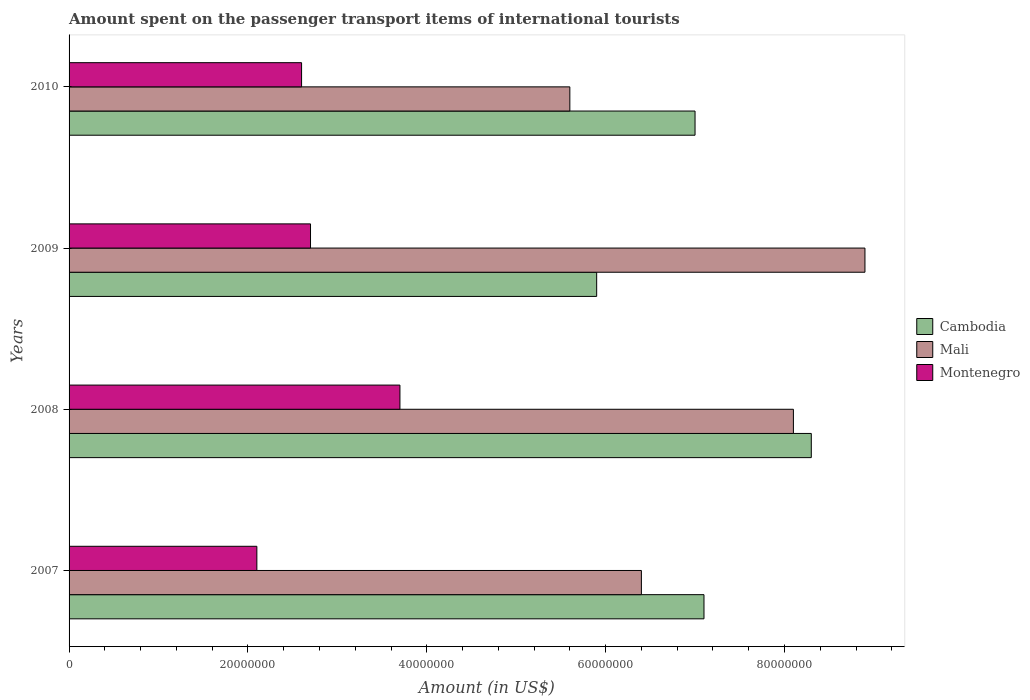How many different coloured bars are there?
Your answer should be compact. 3. Are the number of bars on each tick of the Y-axis equal?
Offer a very short reply. Yes. In how many cases, is the number of bars for a given year not equal to the number of legend labels?
Provide a succinct answer. 0. What is the amount spent on the passenger transport items of international tourists in Montenegro in 2008?
Ensure brevity in your answer.  3.70e+07. Across all years, what is the maximum amount spent on the passenger transport items of international tourists in Mali?
Provide a short and direct response. 8.90e+07. Across all years, what is the minimum amount spent on the passenger transport items of international tourists in Mali?
Keep it short and to the point. 5.60e+07. In which year was the amount spent on the passenger transport items of international tourists in Montenegro maximum?
Ensure brevity in your answer.  2008. What is the total amount spent on the passenger transport items of international tourists in Mali in the graph?
Provide a short and direct response. 2.90e+08. What is the difference between the amount spent on the passenger transport items of international tourists in Cambodia in 2007 and that in 2008?
Give a very brief answer. -1.20e+07. What is the difference between the amount spent on the passenger transport items of international tourists in Mali in 2008 and the amount spent on the passenger transport items of international tourists in Montenegro in 2007?
Provide a succinct answer. 6.00e+07. What is the average amount spent on the passenger transport items of international tourists in Mali per year?
Your answer should be compact. 7.25e+07. In the year 2009, what is the difference between the amount spent on the passenger transport items of international tourists in Mali and amount spent on the passenger transport items of international tourists in Cambodia?
Provide a short and direct response. 3.00e+07. In how many years, is the amount spent on the passenger transport items of international tourists in Cambodia greater than 4000000 US$?
Offer a very short reply. 4. What is the ratio of the amount spent on the passenger transport items of international tourists in Cambodia in 2007 to that in 2010?
Make the answer very short. 1.01. Is the difference between the amount spent on the passenger transport items of international tourists in Mali in 2007 and 2010 greater than the difference between the amount spent on the passenger transport items of international tourists in Cambodia in 2007 and 2010?
Give a very brief answer. Yes. What is the difference between the highest and the second highest amount spent on the passenger transport items of international tourists in Mali?
Provide a succinct answer. 8.00e+06. What is the difference between the highest and the lowest amount spent on the passenger transport items of international tourists in Mali?
Provide a short and direct response. 3.30e+07. In how many years, is the amount spent on the passenger transport items of international tourists in Montenegro greater than the average amount spent on the passenger transport items of international tourists in Montenegro taken over all years?
Ensure brevity in your answer.  1. Is the sum of the amount spent on the passenger transport items of international tourists in Cambodia in 2008 and 2010 greater than the maximum amount spent on the passenger transport items of international tourists in Montenegro across all years?
Provide a succinct answer. Yes. What does the 1st bar from the top in 2007 represents?
Give a very brief answer. Montenegro. What does the 2nd bar from the bottom in 2007 represents?
Your answer should be very brief. Mali. What is the difference between two consecutive major ticks on the X-axis?
Keep it short and to the point. 2.00e+07. Are the values on the major ticks of X-axis written in scientific E-notation?
Offer a very short reply. No. Does the graph contain grids?
Your answer should be very brief. No. How many legend labels are there?
Give a very brief answer. 3. How are the legend labels stacked?
Offer a very short reply. Vertical. What is the title of the graph?
Your answer should be very brief. Amount spent on the passenger transport items of international tourists. Does "Chile" appear as one of the legend labels in the graph?
Ensure brevity in your answer.  No. What is the label or title of the X-axis?
Provide a succinct answer. Amount (in US$). What is the label or title of the Y-axis?
Offer a very short reply. Years. What is the Amount (in US$) of Cambodia in 2007?
Your answer should be very brief. 7.10e+07. What is the Amount (in US$) in Mali in 2007?
Provide a succinct answer. 6.40e+07. What is the Amount (in US$) in Montenegro in 2007?
Your response must be concise. 2.10e+07. What is the Amount (in US$) of Cambodia in 2008?
Make the answer very short. 8.30e+07. What is the Amount (in US$) in Mali in 2008?
Provide a short and direct response. 8.10e+07. What is the Amount (in US$) of Montenegro in 2008?
Ensure brevity in your answer.  3.70e+07. What is the Amount (in US$) of Cambodia in 2009?
Make the answer very short. 5.90e+07. What is the Amount (in US$) in Mali in 2009?
Ensure brevity in your answer.  8.90e+07. What is the Amount (in US$) of Montenegro in 2009?
Provide a short and direct response. 2.70e+07. What is the Amount (in US$) of Cambodia in 2010?
Keep it short and to the point. 7.00e+07. What is the Amount (in US$) in Mali in 2010?
Provide a succinct answer. 5.60e+07. What is the Amount (in US$) of Montenegro in 2010?
Offer a very short reply. 2.60e+07. Across all years, what is the maximum Amount (in US$) in Cambodia?
Your answer should be very brief. 8.30e+07. Across all years, what is the maximum Amount (in US$) in Mali?
Your response must be concise. 8.90e+07. Across all years, what is the maximum Amount (in US$) in Montenegro?
Your response must be concise. 3.70e+07. Across all years, what is the minimum Amount (in US$) in Cambodia?
Ensure brevity in your answer.  5.90e+07. Across all years, what is the minimum Amount (in US$) of Mali?
Provide a short and direct response. 5.60e+07. Across all years, what is the minimum Amount (in US$) in Montenegro?
Your answer should be compact. 2.10e+07. What is the total Amount (in US$) in Cambodia in the graph?
Your answer should be very brief. 2.83e+08. What is the total Amount (in US$) of Mali in the graph?
Make the answer very short. 2.90e+08. What is the total Amount (in US$) of Montenegro in the graph?
Offer a terse response. 1.11e+08. What is the difference between the Amount (in US$) of Cambodia in 2007 and that in 2008?
Your response must be concise. -1.20e+07. What is the difference between the Amount (in US$) in Mali in 2007 and that in 2008?
Offer a terse response. -1.70e+07. What is the difference between the Amount (in US$) of Montenegro in 2007 and that in 2008?
Your answer should be compact. -1.60e+07. What is the difference between the Amount (in US$) in Cambodia in 2007 and that in 2009?
Your answer should be very brief. 1.20e+07. What is the difference between the Amount (in US$) in Mali in 2007 and that in 2009?
Keep it short and to the point. -2.50e+07. What is the difference between the Amount (in US$) of Montenegro in 2007 and that in 2009?
Give a very brief answer. -6.00e+06. What is the difference between the Amount (in US$) of Mali in 2007 and that in 2010?
Offer a terse response. 8.00e+06. What is the difference between the Amount (in US$) in Montenegro in 2007 and that in 2010?
Provide a succinct answer. -5.00e+06. What is the difference between the Amount (in US$) of Cambodia in 2008 and that in 2009?
Provide a short and direct response. 2.40e+07. What is the difference between the Amount (in US$) in Mali in 2008 and that in 2009?
Make the answer very short. -8.00e+06. What is the difference between the Amount (in US$) in Cambodia in 2008 and that in 2010?
Your answer should be compact. 1.30e+07. What is the difference between the Amount (in US$) in Mali in 2008 and that in 2010?
Give a very brief answer. 2.50e+07. What is the difference between the Amount (in US$) of Montenegro in 2008 and that in 2010?
Give a very brief answer. 1.10e+07. What is the difference between the Amount (in US$) of Cambodia in 2009 and that in 2010?
Provide a succinct answer. -1.10e+07. What is the difference between the Amount (in US$) in Mali in 2009 and that in 2010?
Offer a terse response. 3.30e+07. What is the difference between the Amount (in US$) in Montenegro in 2009 and that in 2010?
Keep it short and to the point. 1.00e+06. What is the difference between the Amount (in US$) in Cambodia in 2007 and the Amount (in US$) in Mali in 2008?
Offer a very short reply. -1.00e+07. What is the difference between the Amount (in US$) in Cambodia in 2007 and the Amount (in US$) in Montenegro in 2008?
Make the answer very short. 3.40e+07. What is the difference between the Amount (in US$) of Mali in 2007 and the Amount (in US$) of Montenegro in 2008?
Keep it short and to the point. 2.70e+07. What is the difference between the Amount (in US$) of Cambodia in 2007 and the Amount (in US$) of Mali in 2009?
Offer a terse response. -1.80e+07. What is the difference between the Amount (in US$) of Cambodia in 2007 and the Amount (in US$) of Montenegro in 2009?
Your answer should be compact. 4.40e+07. What is the difference between the Amount (in US$) of Mali in 2007 and the Amount (in US$) of Montenegro in 2009?
Provide a short and direct response. 3.70e+07. What is the difference between the Amount (in US$) in Cambodia in 2007 and the Amount (in US$) in Mali in 2010?
Give a very brief answer. 1.50e+07. What is the difference between the Amount (in US$) in Cambodia in 2007 and the Amount (in US$) in Montenegro in 2010?
Give a very brief answer. 4.50e+07. What is the difference between the Amount (in US$) of Mali in 2007 and the Amount (in US$) of Montenegro in 2010?
Keep it short and to the point. 3.80e+07. What is the difference between the Amount (in US$) of Cambodia in 2008 and the Amount (in US$) of Mali in 2009?
Provide a succinct answer. -6.00e+06. What is the difference between the Amount (in US$) in Cambodia in 2008 and the Amount (in US$) in Montenegro in 2009?
Your answer should be very brief. 5.60e+07. What is the difference between the Amount (in US$) of Mali in 2008 and the Amount (in US$) of Montenegro in 2009?
Your response must be concise. 5.40e+07. What is the difference between the Amount (in US$) in Cambodia in 2008 and the Amount (in US$) in Mali in 2010?
Provide a short and direct response. 2.70e+07. What is the difference between the Amount (in US$) in Cambodia in 2008 and the Amount (in US$) in Montenegro in 2010?
Your answer should be compact. 5.70e+07. What is the difference between the Amount (in US$) in Mali in 2008 and the Amount (in US$) in Montenegro in 2010?
Provide a short and direct response. 5.50e+07. What is the difference between the Amount (in US$) of Cambodia in 2009 and the Amount (in US$) of Montenegro in 2010?
Give a very brief answer. 3.30e+07. What is the difference between the Amount (in US$) of Mali in 2009 and the Amount (in US$) of Montenegro in 2010?
Make the answer very short. 6.30e+07. What is the average Amount (in US$) of Cambodia per year?
Give a very brief answer. 7.08e+07. What is the average Amount (in US$) in Mali per year?
Provide a short and direct response. 7.25e+07. What is the average Amount (in US$) of Montenegro per year?
Make the answer very short. 2.78e+07. In the year 2007, what is the difference between the Amount (in US$) in Mali and Amount (in US$) in Montenegro?
Offer a very short reply. 4.30e+07. In the year 2008, what is the difference between the Amount (in US$) of Cambodia and Amount (in US$) of Montenegro?
Ensure brevity in your answer.  4.60e+07. In the year 2008, what is the difference between the Amount (in US$) in Mali and Amount (in US$) in Montenegro?
Offer a very short reply. 4.40e+07. In the year 2009, what is the difference between the Amount (in US$) in Cambodia and Amount (in US$) in Mali?
Provide a short and direct response. -3.00e+07. In the year 2009, what is the difference between the Amount (in US$) in Cambodia and Amount (in US$) in Montenegro?
Your answer should be compact. 3.20e+07. In the year 2009, what is the difference between the Amount (in US$) of Mali and Amount (in US$) of Montenegro?
Provide a succinct answer. 6.20e+07. In the year 2010, what is the difference between the Amount (in US$) in Cambodia and Amount (in US$) in Mali?
Your response must be concise. 1.40e+07. In the year 2010, what is the difference between the Amount (in US$) in Cambodia and Amount (in US$) in Montenegro?
Your answer should be compact. 4.40e+07. In the year 2010, what is the difference between the Amount (in US$) in Mali and Amount (in US$) in Montenegro?
Ensure brevity in your answer.  3.00e+07. What is the ratio of the Amount (in US$) in Cambodia in 2007 to that in 2008?
Your response must be concise. 0.86. What is the ratio of the Amount (in US$) in Mali in 2007 to that in 2008?
Ensure brevity in your answer.  0.79. What is the ratio of the Amount (in US$) of Montenegro in 2007 to that in 2008?
Provide a succinct answer. 0.57. What is the ratio of the Amount (in US$) in Cambodia in 2007 to that in 2009?
Offer a terse response. 1.2. What is the ratio of the Amount (in US$) in Mali in 2007 to that in 2009?
Offer a terse response. 0.72. What is the ratio of the Amount (in US$) in Cambodia in 2007 to that in 2010?
Give a very brief answer. 1.01. What is the ratio of the Amount (in US$) in Mali in 2007 to that in 2010?
Keep it short and to the point. 1.14. What is the ratio of the Amount (in US$) in Montenegro in 2007 to that in 2010?
Offer a terse response. 0.81. What is the ratio of the Amount (in US$) in Cambodia in 2008 to that in 2009?
Your response must be concise. 1.41. What is the ratio of the Amount (in US$) of Mali in 2008 to that in 2009?
Make the answer very short. 0.91. What is the ratio of the Amount (in US$) in Montenegro in 2008 to that in 2009?
Give a very brief answer. 1.37. What is the ratio of the Amount (in US$) of Cambodia in 2008 to that in 2010?
Offer a terse response. 1.19. What is the ratio of the Amount (in US$) of Mali in 2008 to that in 2010?
Provide a succinct answer. 1.45. What is the ratio of the Amount (in US$) in Montenegro in 2008 to that in 2010?
Keep it short and to the point. 1.42. What is the ratio of the Amount (in US$) of Cambodia in 2009 to that in 2010?
Your answer should be very brief. 0.84. What is the ratio of the Amount (in US$) in Mali in 2009 to that in 2010?
Give a very brief answer. 1.59. What is the ratio of the Amount (in US$) in Montenegro in 2009 to that in 2010?
Your answer should be compact. 1.04. What is the difference between the highest and the second highest Amount (in US$) in Montenegro?
Give a very brief answer. 1.00e+07. What is the difference between the highest and the lowest Amount (in US$) of Cambodia?
Ensure brevity in your answer.  2.40e+07. What is the difference between the highest and the lowest Amount (in US$) in Mali?
Keep it short and to the point. 3.30e+07. What is the difference between the highest and the lowest Amount (in US$) of Montenegro?
Offer a terse response. 1.60e+07. 